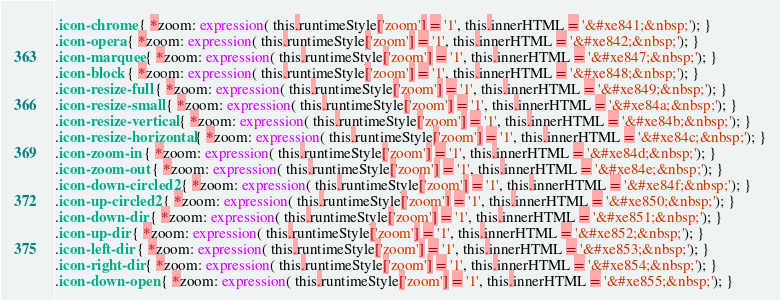Convert code to text. <code><loc_0><loc_0><loc_500><loc_500><_CSS_>.icon-chrome { *zoom: expression( this.runtimeStyle['zoom'] = '1', this.innerHTML = '&#xe841;&nbsp;'); }
.icon-opera { *zoom: expression( this.runtimeStyle['zoom'] = '1', this.innerHTML = '&#xe842;&nbsp;'); }
.icon-marquee { *zoom: expression( this.runtimeStyle['zoom'] = '1', this.innerHTML = '&#xe847;&nbsp;'); }
.icon-block { *zoom: expression( this.runtimeStyle['zoom'] = '1', this.innerHTML = '&#xe848;&nbsp;'); }
.icon-resize-full { *zoom: expression( this.runtimeStyle['zoom'] = '1', this.innerHTML = '&#xe849;&nbsp;'); }
.icon-resize-small { *zoom: expression( this.runtimeStyle['zoom'] = '1', this.innerHTML = '&#xe84a;&nbsp;'); }
.icon-resize-vertical { *zoom: expression( this.runtimeStyle['zoom'] = '1', this.innerHTML = '&#xe84b;&nbsp;'); }
.icon-resize-horizontal { *zoom: expression( this.runtimeStyle['zoom'] = '1', this.innerHTML = '&#xe84c;&nbsp;'); }
.icon-zoom-in { *zoom: expression( this.runtimeStyle['zoom'] = '1', this.innerHTML = '&#xe84d;&nbsp;'); }
.icon-zoom-out { *zoom: expression( this.runtimeStyle['zoom'] = '1', this.innerHTML = '&#xe84e;&nbsp;'); }
.icon-down-circled2 { *zoom: expression( this.runtimeStyle['zoom'] = '1', this.innerHTML = '&#xe84f;&nbsp;'); }
.icon-up-circled2 { *zoom: expression( this.runtimeStyle['zoom'] = '1', this.innerHTML = '&#xe850;&nbsp;'); }
.icon-down-dir { *zoom: expression( this.runtimeStyle['zoom'] = '1', this.innerHTML = '&#xe851;&nbsp;'); }
.icon-up-dir { *zoom: expression( this.runtimeStyle['zoom'] = '1', this.innerHTML = '&#xe852;&nbsp;'); }
.icon-left-dir { *zoom: expression( this.runtimeStyle['zoom'] = '1', this.innerHTML = '&#xe853;&nbsp;'); }
.icon-right-dir { *zoom: expression( this.runtimeStyle['zoom'] = '1', this.innerHTML = '&#xe854;&nbsp;'); }
.icon-down-open { *zoom: expression( this.runtimeStyle['zoom'] = '1', this.innerHTML = '&#xe855;&nbsp;'); }</code> 